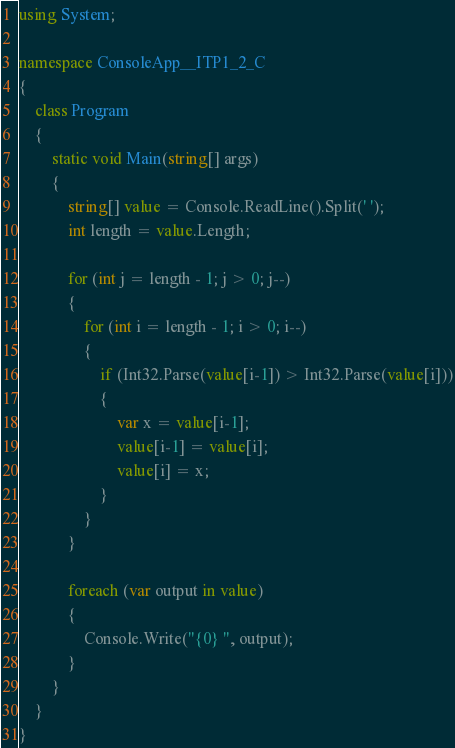<code> <loc_0><loc_0><loc_500><loc_500><_C#_>using System;

namespace ConsoleApp__ITP1_2_C
{
    class Program
    {
        static void Main(string[] args)
        {
            string[] value = Console.ReadLine().Split(' ');
            int length = value.Length;

            for (int j = length - 1; j > 0; j--)
            {
                for (int i = length - 1; i > 0; i--)
                {
                    if (Int32.Parse(value[i-1]) > Int32.Parse(value[i]))
                    {
                        var x = value[i-1];
                        value[i-1] = value[i];
                        value[i] = x;
                    }
                }
            }

            foreach (var output in value)
            {
                Console.Write("{0} ", output);
            }
        }
    }
}

</code> 